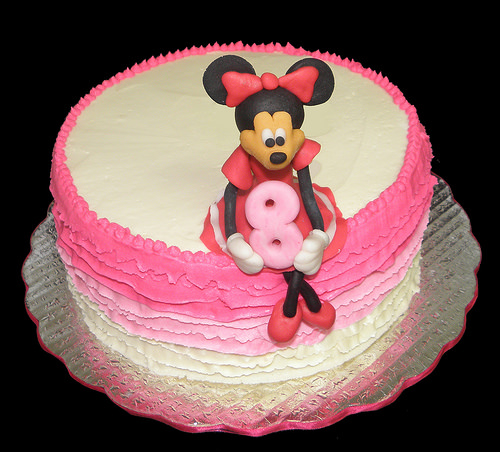<image>
Is there a minnie in the cake? No. The minnie is not contained within the cake. These objects have a different spatial relationship. Where is the minnie mouse in relation to the cake? Is it on the cake? Yes. Looking at the image, I can see the minnie mouse is positioned on top of the cake, with the cake providing support. Is the mouse on the cake? Yes. Looking at the image, I can see the mouse is positioned on top of the cake, with the cake providing support. Is the mickey mouse on the book? No. The mickey mouse is not positioned on the book. They may be near each other, but the mickey mouse is not supported by or resting on top of the book. 